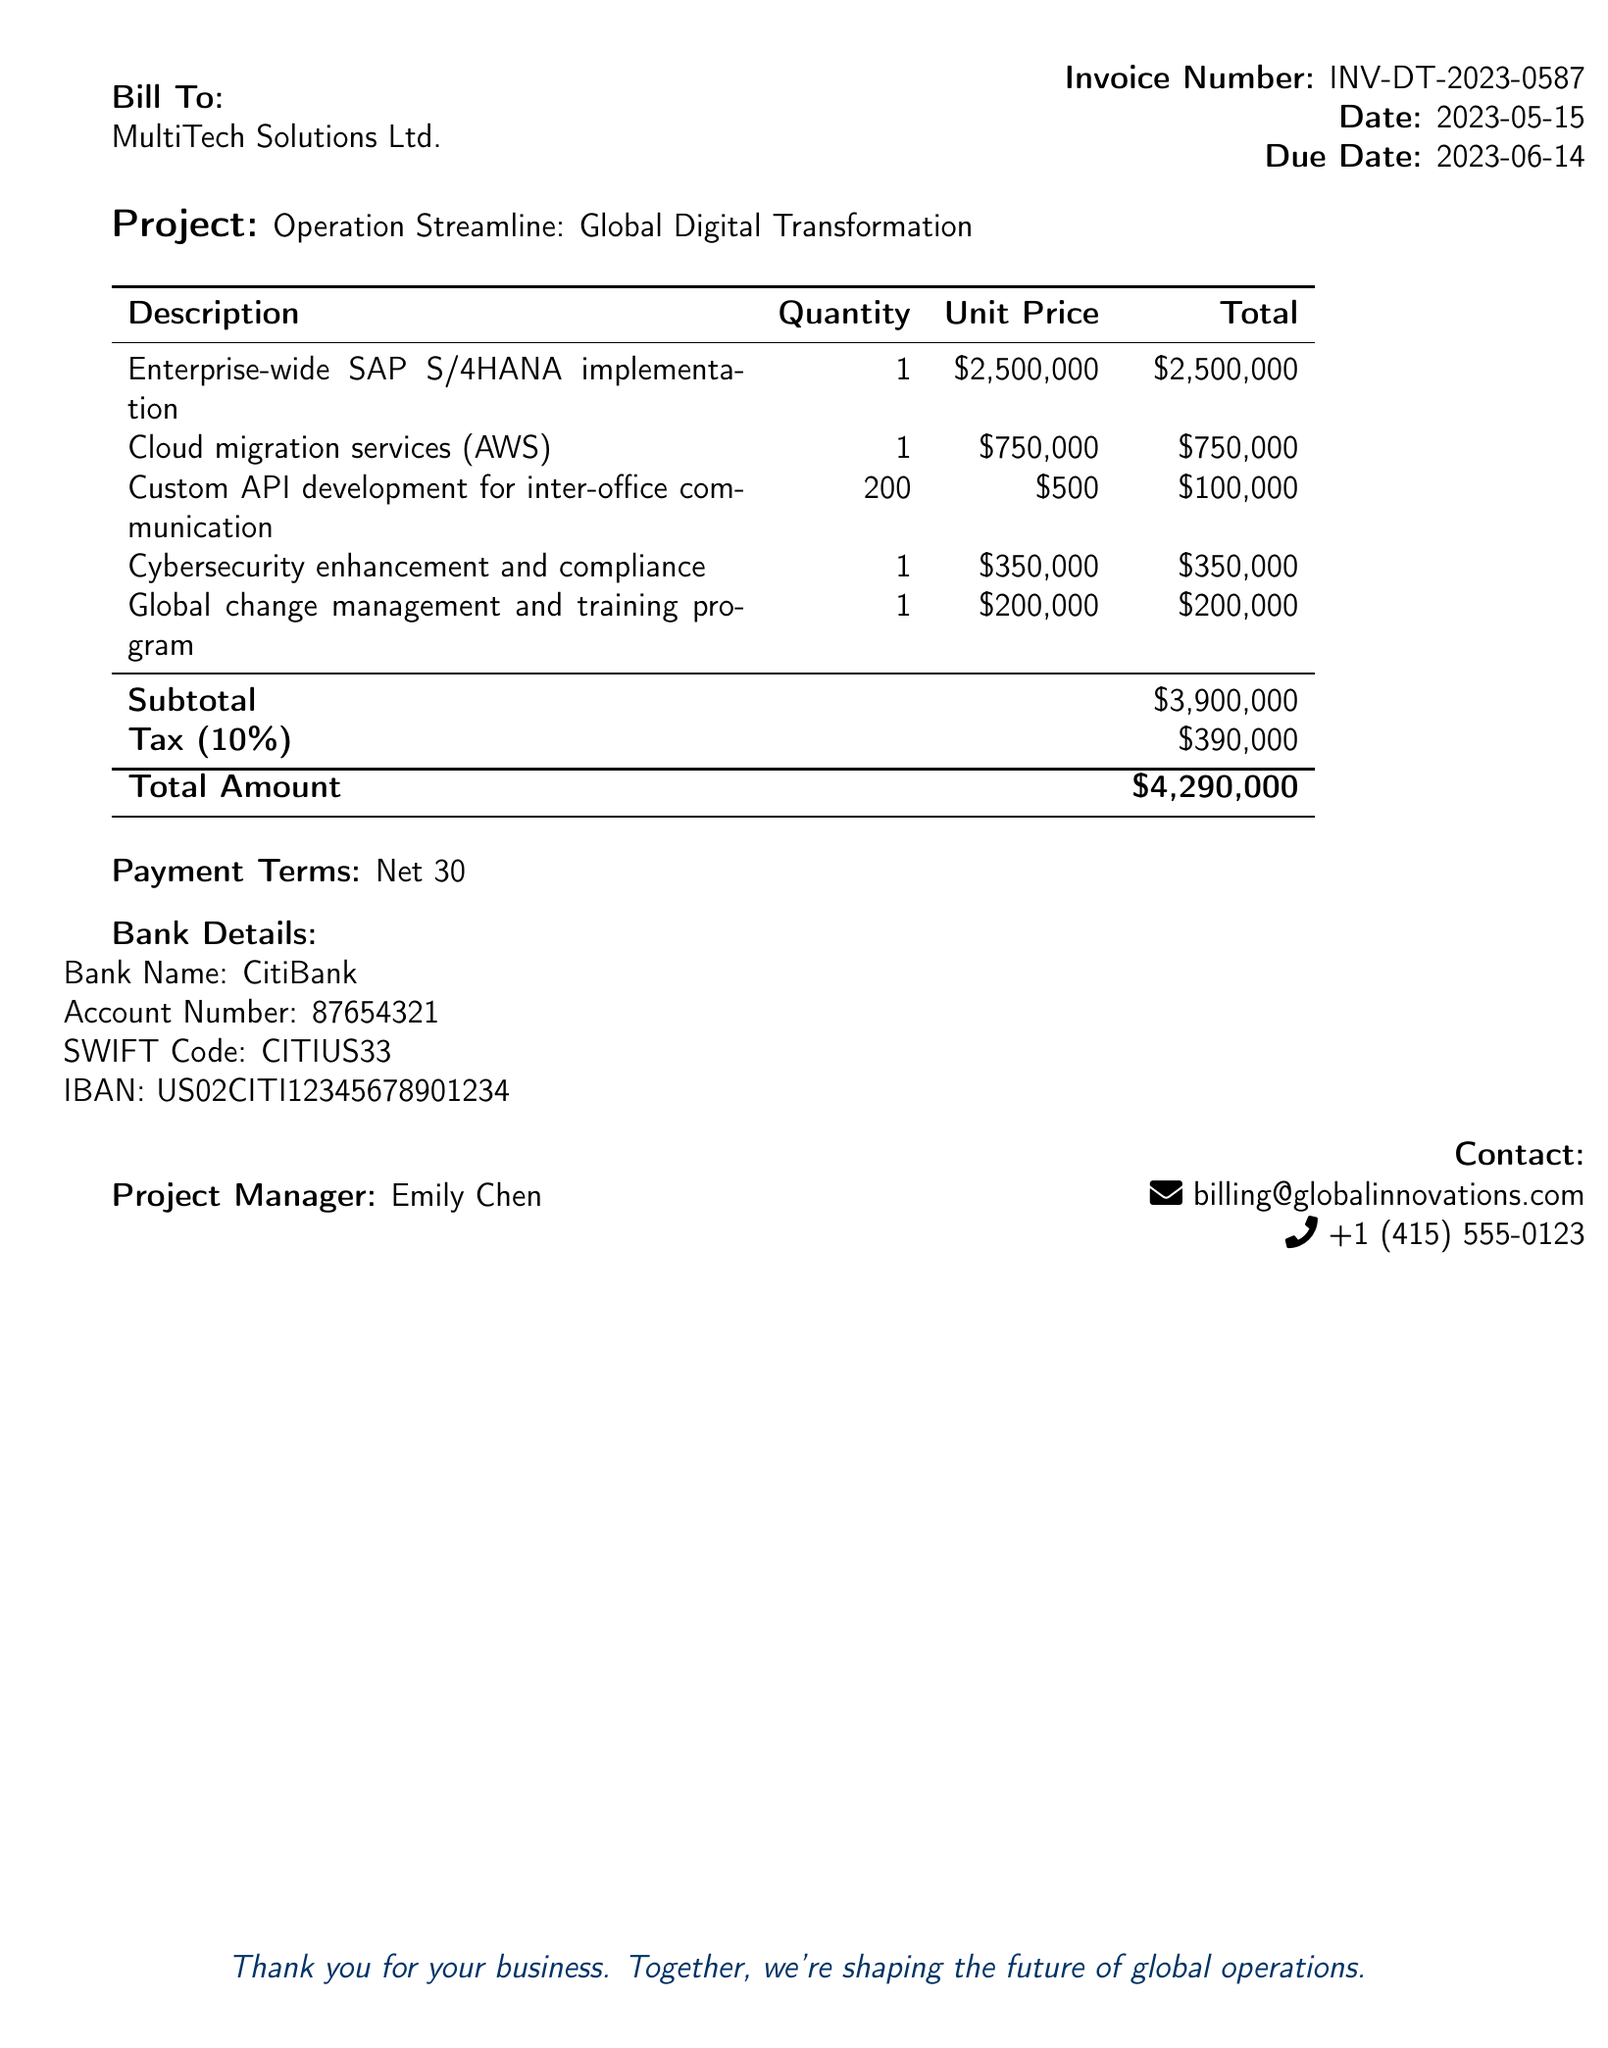What is the invoice number? The invoice number is listed at the top of the document for reference purposes.
Answer: INV-DT-2023-0587 What is the total amount due? The total amount due is presented at the end of the invoice and includes all costs and taxes.
Answer: $4,290,000 Who is the project manager? The project manager's name is specified in the contact information section of the document.
Answer: Emily Chen What is the tax percentage applied? The tax percentage is mentioned directly in the tax line of the invoice.
Answer: 10% How many custom API developments were charged? The quantity of custom API developments is stated in the invoice breakdown table.
Answer: 200 What payment terms are provided? The payment terms are listed near the end of the document, specifying when payment is due.
Answer: Net 30 What is the due date for payment? The due date is provided alongside the invoice date.
Answer: 2023-06-14 What services are included in the subtotal? The subtotal includes various service costs listed in the breakdown before taxes.
Answer: $3,900,000 Which bank is specified for wire transfers? The bank information is listed under the payment details section of the invoice.
Answer: CitiBank 